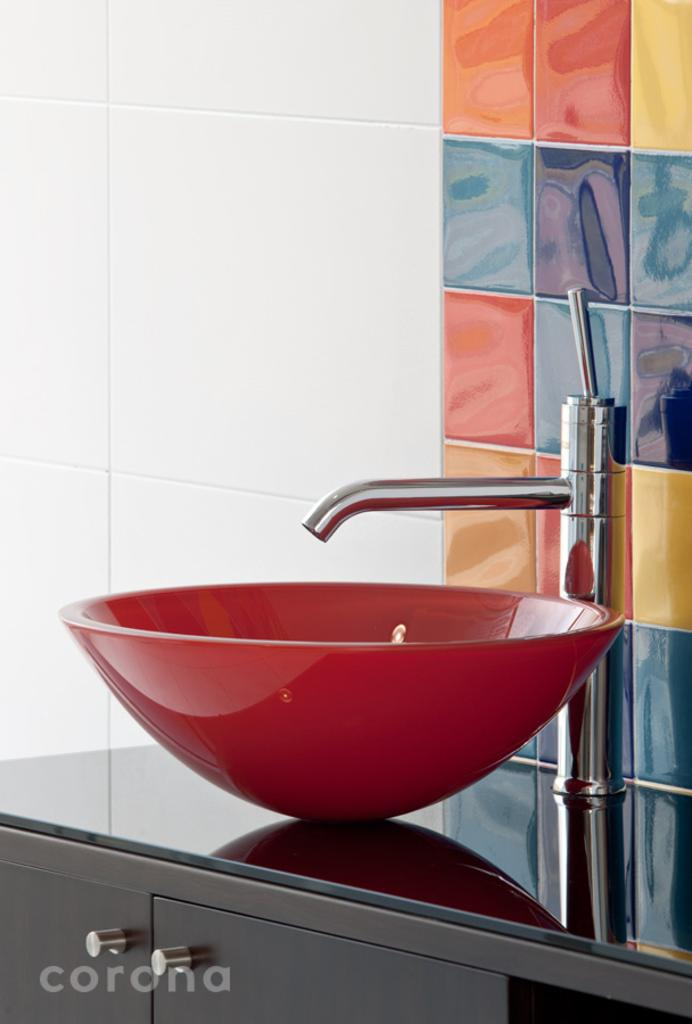What is the main object in the image? There is a tap in the image. What color is the sink that the tap is connected to? The sink is red in color. What type of storage can be seen in the image? There are cupboards in the image. What type of decorative element is present in the background of the image? There are colorful tiles in the background of the image. What type of grape is being used as a decoration on the side of the tap? There are no grapes present in the image, and the tap is not decorated with any fruit. What type of meat is being stored in the cupboards in the image? There is no meat visible in the image, and the cupboards are not shown to contain any food items. 